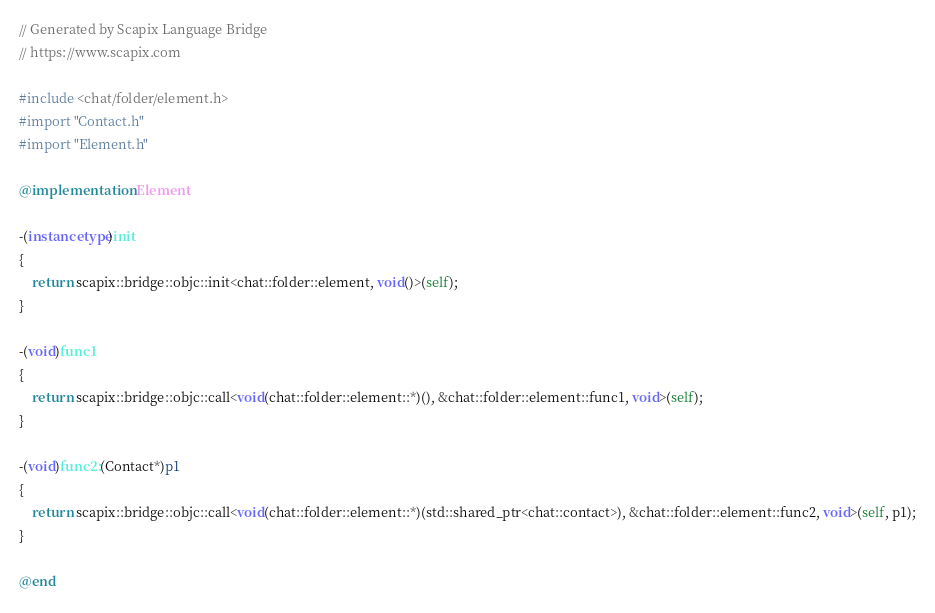<code> <loc_0><loc_0><loc_500><loc_500><_ObjectiveC_>// Generated by Scapix Language Bridge
// https://www.scapix.com

#include <chat/folder/element.h>
#import "Contact.h"
#import "Element.h"

@implementation Element

-(instancetype)init
{
	return scapix::bridge::objc::init<chat::folder::element, void()>(self);
}

-(void)func1
{
	return scapix::bridge::objc::call<void(chat::folder::element::*)(), &chat::folder::element::func1, void>(self);
}

-(void)func2:(Contact*)p1
{
	return scapix::bridge::objc::call<void(chat::folder::element::*)(std::shared_ptr<chat::contact>), &chat::folder::element::func2, void>(self, p1);
}

@end
</code> 